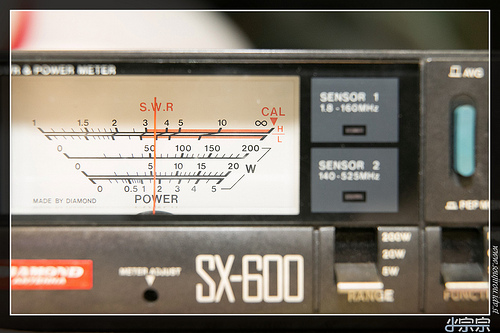<image>
Is the power meter to the left of the switch? Yes. From this viewpoint, the power meter is positioned to the left side relative to the switch. 